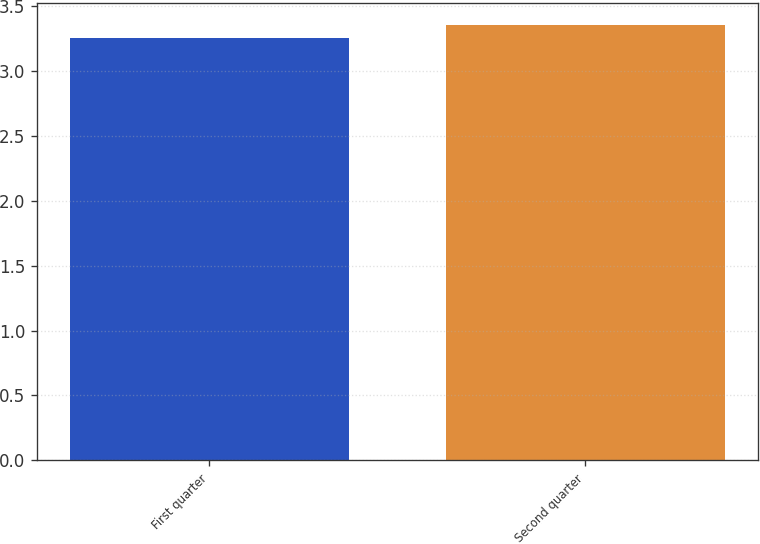<chart> <loc_0><loc_0><loc_500><loc_500><bar_chart><fcel>First quarter<fcel>Second quarter<nl><fcel>3.25<fcel>3.35<nl></chart> 